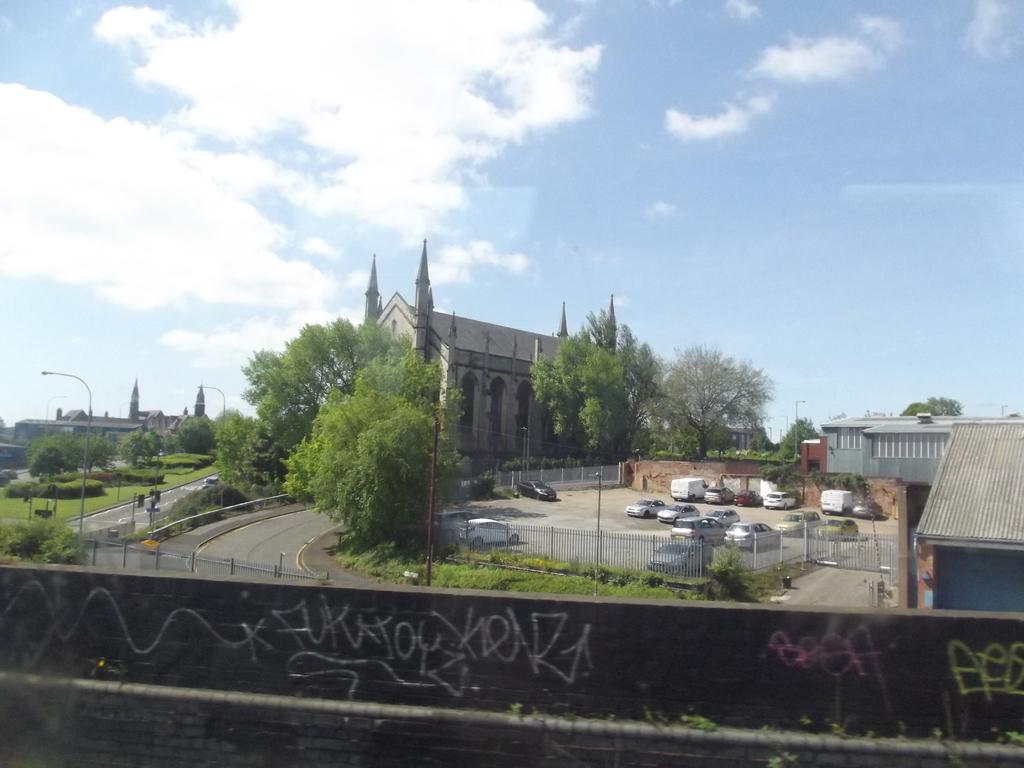<image>
Share a concise interpretation of the image provided. Graffiti on a wall overlooking a church and carpark starts with the letters FUK in white. 